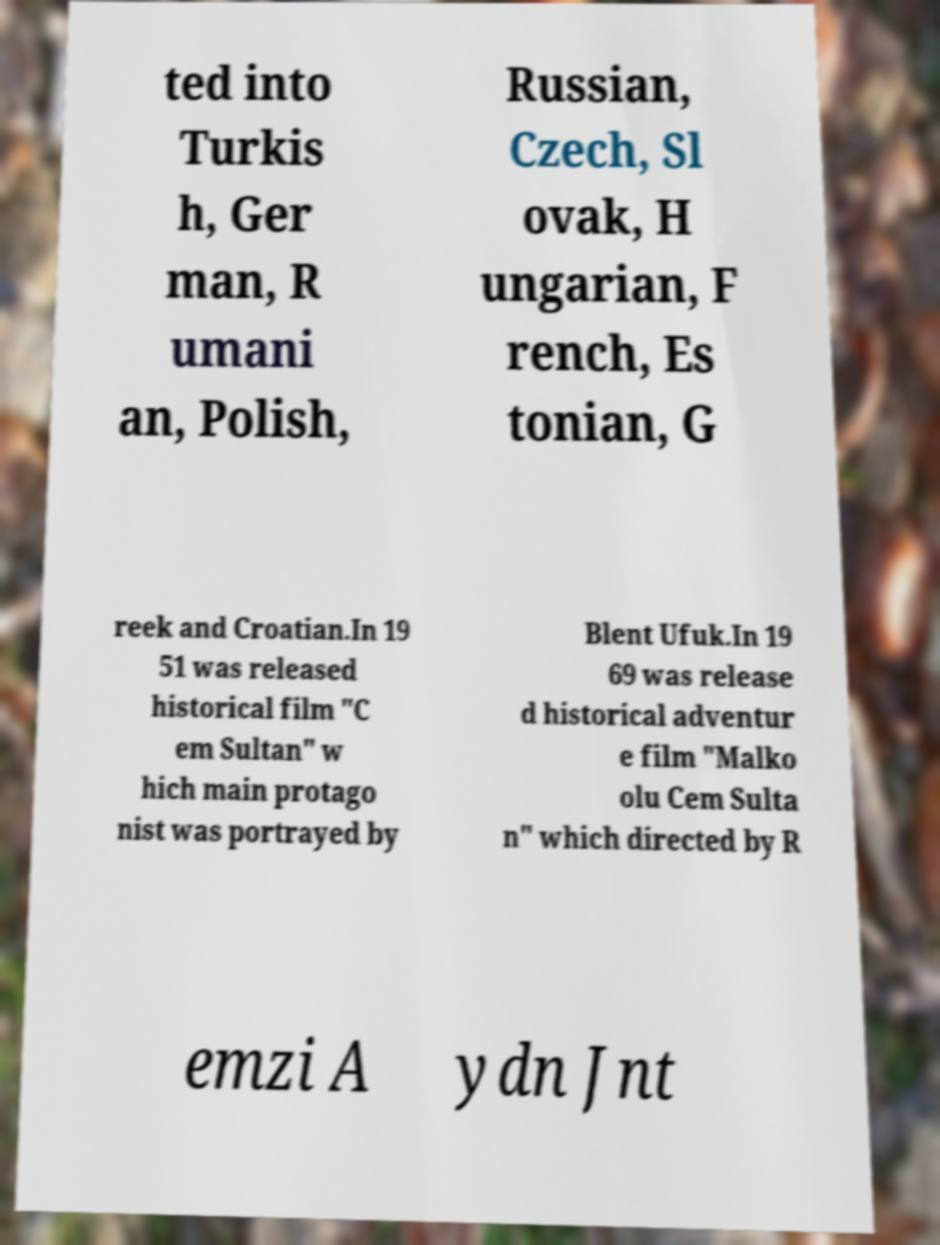Can you accurately transcribe the text from the provided image for me? ted into Turkis h, Ger man, R umani an, Polish, Russian, Czech, Sl ovak, H ungarian, F rench, Es tonian, G reek and Croatian.In 19 51 was released historical film "C em Sultan" w hich main protago nist was portrayed by Blent Ufuk.In 19 69 was release d historical adventur e film "Malko olu Cem Sulta n" which directed by R emzi A ydn Jnt 